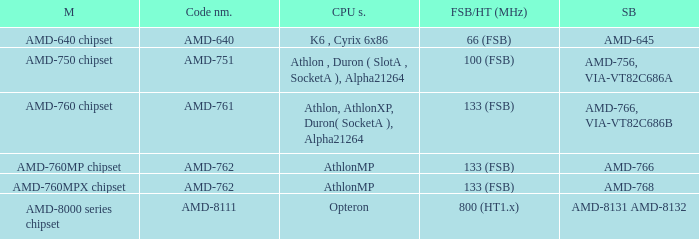What is the code name when the FSB / HT (MHz) is 100 (fsb)? AMD-751. 